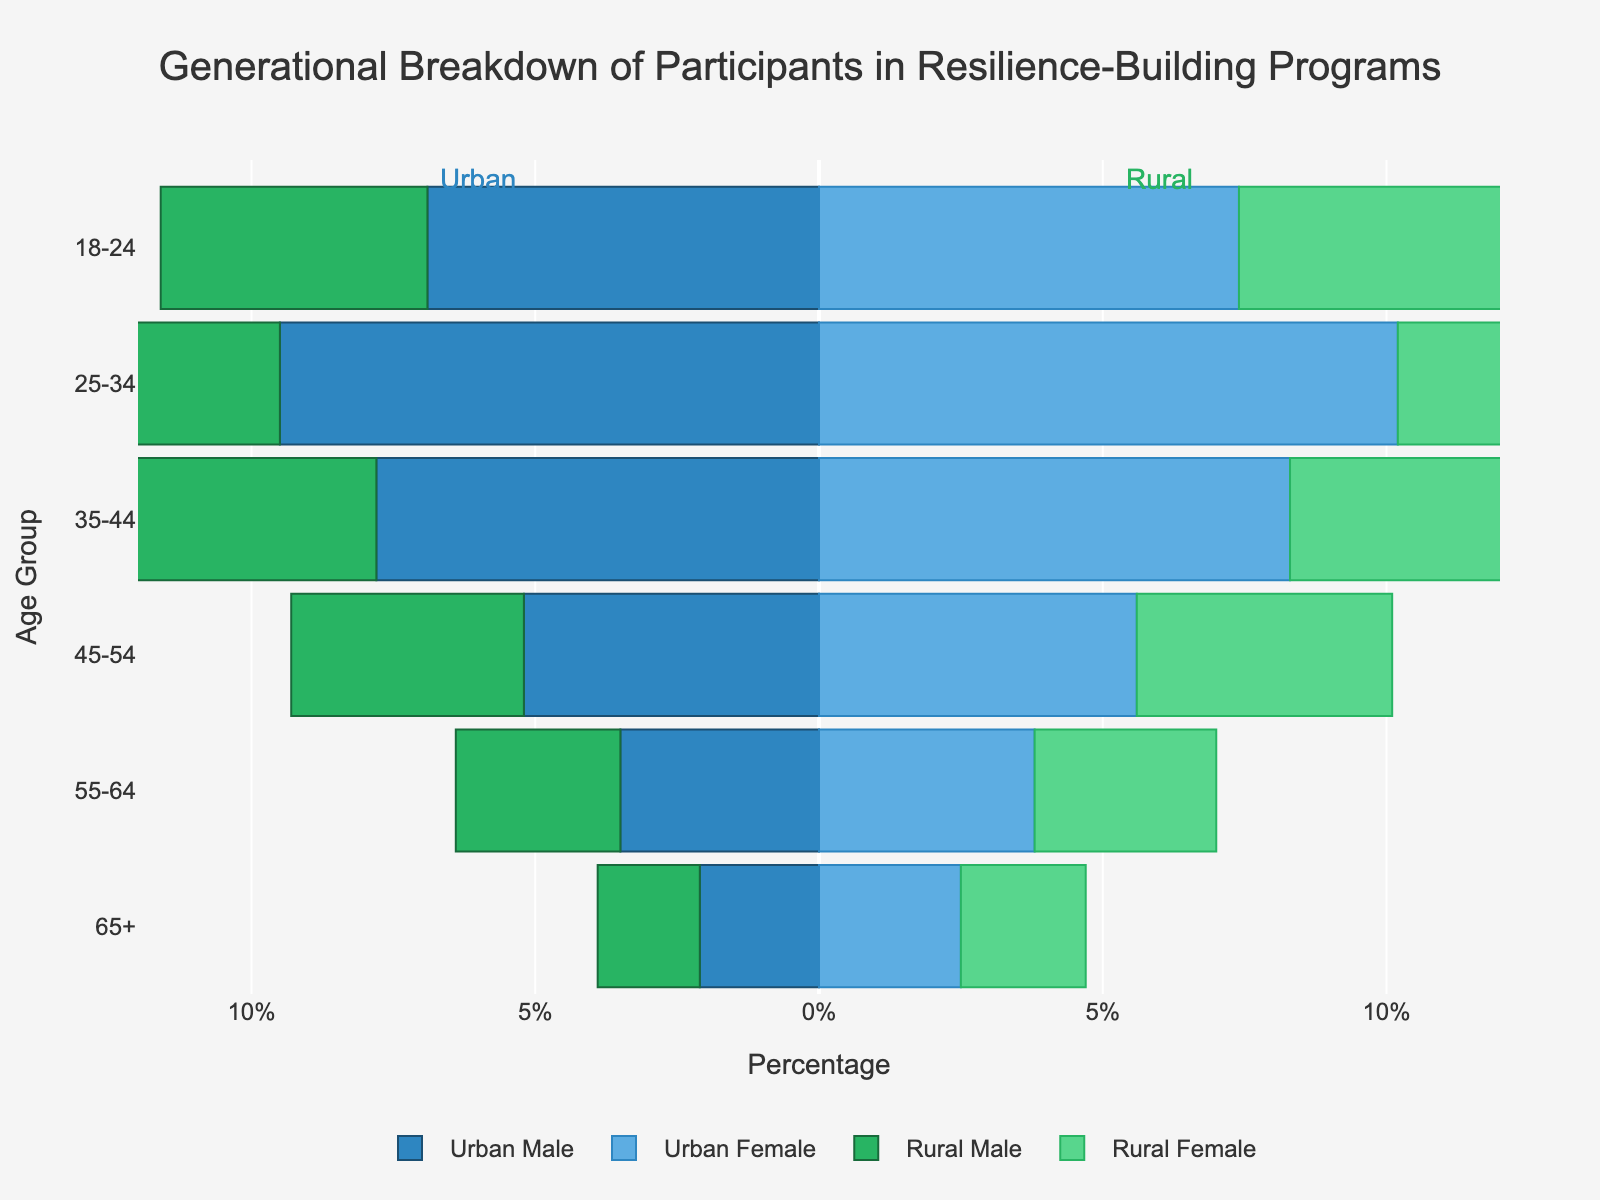What is the title of the plot? The title is usually displayed at the top of the plot, indicating its content. In this case, it reads "Generational Breakdown of Participants in Resilience-Building Programs."
Answer: Generational Breakdown of Participants in Resilience-Building Programs Which age group has the highest percentage of Urban Female participants? By examining the Urban Female bars, we see that the 25-34 age group has the longest bar, indicating the highest percentage.
Answer: 25-34 What percentage of Rural Female participants are in the 18-24 age group? Look at the bar corresponding to Rural Female for the 18-24 age group. The length of the bar shows the percentage, which is 5.1%.
Answer: 5.1% How does the percentage of Urban Male participants in the 35-44 age group compare to Rural Male participants in the same age group? Check the lengths of the bars corresponding to Urban Male and Rural Male for the 35-44 age group. The Urban Male percentage is longer and measures 7.8%, compared to the shorter Rural Male percentage of 5.6%.
Answer: Urban Male participation is greater at 7.8% compared to Rural Male at 5.6% What is the total percentage of participants from the 45-54 age group in rural areas (both male and female)? Add the percentages of Rural Male and Rural Female participants in the 45-54 age group: 4.1% (Male) + 4.5% (Female) = 8.6%.
Answer: 8.6% Between Urban and Rural areas, which has a higher percentage of Male participants aged 55-64? Compare the lengths of the bars for Urban Male and Rural Male in the 55-64 age group. The Urban Male bar is longer at 3.5%, while the Rural Male bar is shorter at 2.9%.
Answer: Urban What is the difference in percentage between Urban Female and Urban Male participants in the 25-34 age group? Subtract the percentage of Urban Male participants from Urban Female participants in the 25-34 age group: 10.2% - 9.5% = 0.7%.
Answer: 0.7% In which age group is the participation of Urban Male and Female closest in percentage? Comparing the bars for Urban Male and Urban Female across all age groups, they are closest for the 65+ age group with percentages 2.1% (Male) and 2.5% (Female) - a difference of 0.4%.
Answer: 65+ Which gender has a higher percentage of participants aged 18-24 in rural areas? Compare the lengths of the bars for Rural Male and Rural Female in the 18-24 age group. The Rural Female bar is longer at 5.1%, compared to the Rural Male at 4.7%.
Answer: Female How does the percentage of Urban participants aged 25-34 compare to Rural participants in the same age group? Sum the percentages of Urban Male and Female (9.5% + 10.2% = 19.7%) and compare with Rural Male and Female (6.8% + 7.3% = 14.1%). Urban participants total 19.7%, which is higher than Rural participants at 14.1%.
Answer: Urban participants have a higher percentage at 19.7% compared to Rural participants at 14.1% 